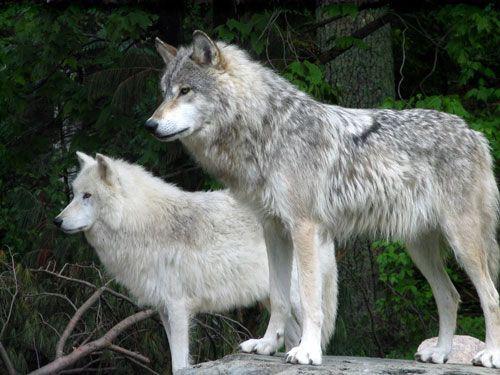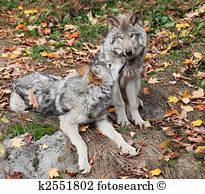The first image is the image on the left, the second image is the image on the right. Examine the images to the left and right. Is the description "The combined images contain three live animals, two animals have wide-open mouths, and at least two of the animals are wolves." accurate? Answer yes or no. No. The first image is the image on the left, the second image is the image on the right. Considering the images on both sides, is "There are three wolves." valid? Answer yes or no. No. 